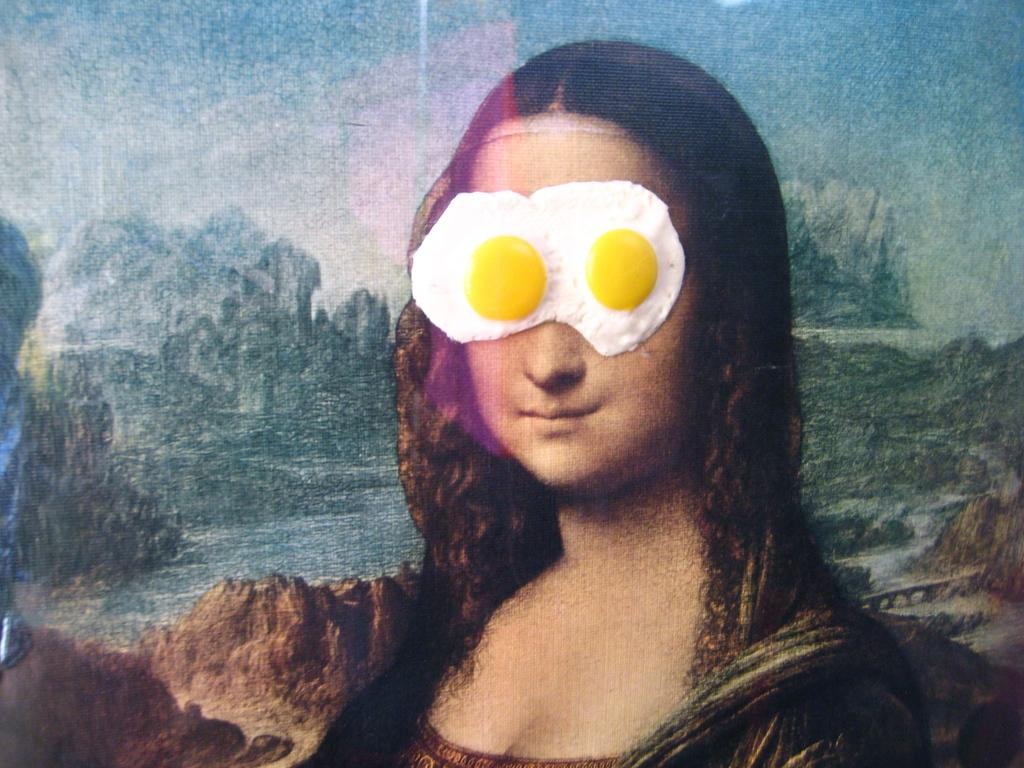What famous artwork is depicted in the image? There is a painting of Mona Lisa in the image. What unusual addition can be seen on the painting? There are two half-boiled eggs on the face of the painting. What type of landscape is visible in the background of the image? There are hills in the background of the image. What part of the natural environment is visible in the image? The sky is visible in the background of the image. What type of beam is holding up the ceiling in the image? There is no mention of a ceiling or any beams in the image; it features a painting of Mona Lisa with half-boiled eggs on the face. How many people are present in the hall in the image? There is no hall or any people present in the image; it features a painting of Mona Lisa with half-boiled eggs on the face. 